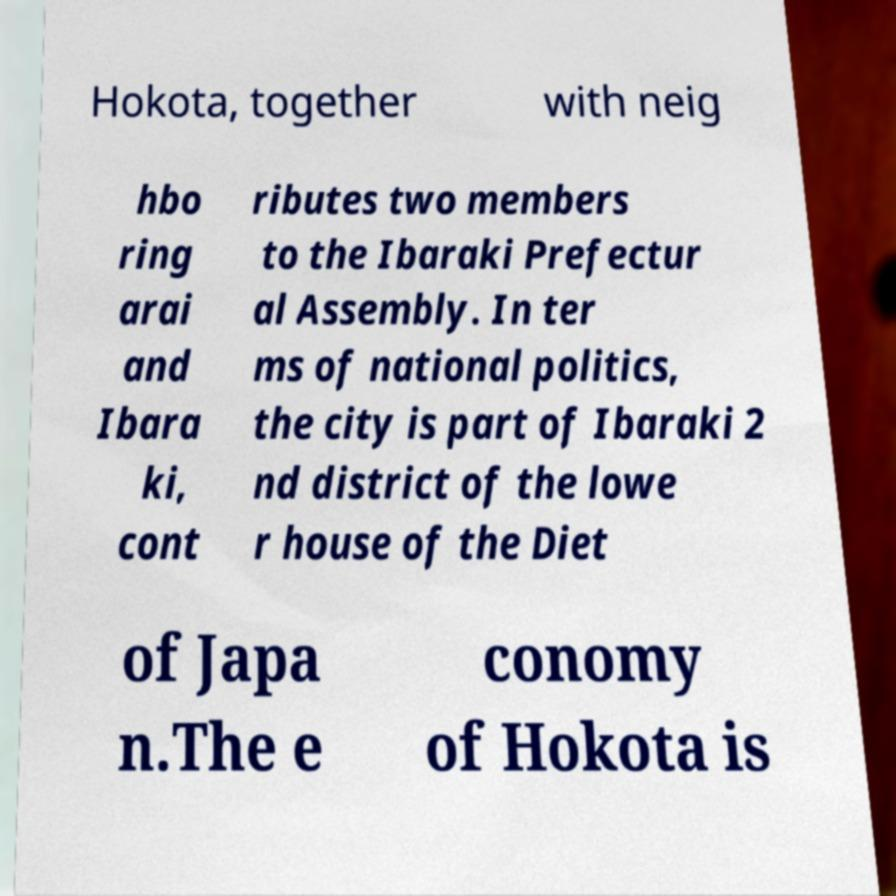There's text embedded in this image that I need extracted. Can you transcribe it verbatim? Hokota, together with neig hbo ring arai and Ibara ki, cont ributes two members to the Ibaraki Prefectur al Assembly. In ter ms of national politics, the city is part of Ibaraki 2 nd district of the lowe r house of the Diet of Japa n.The e conomy of Hokota is 